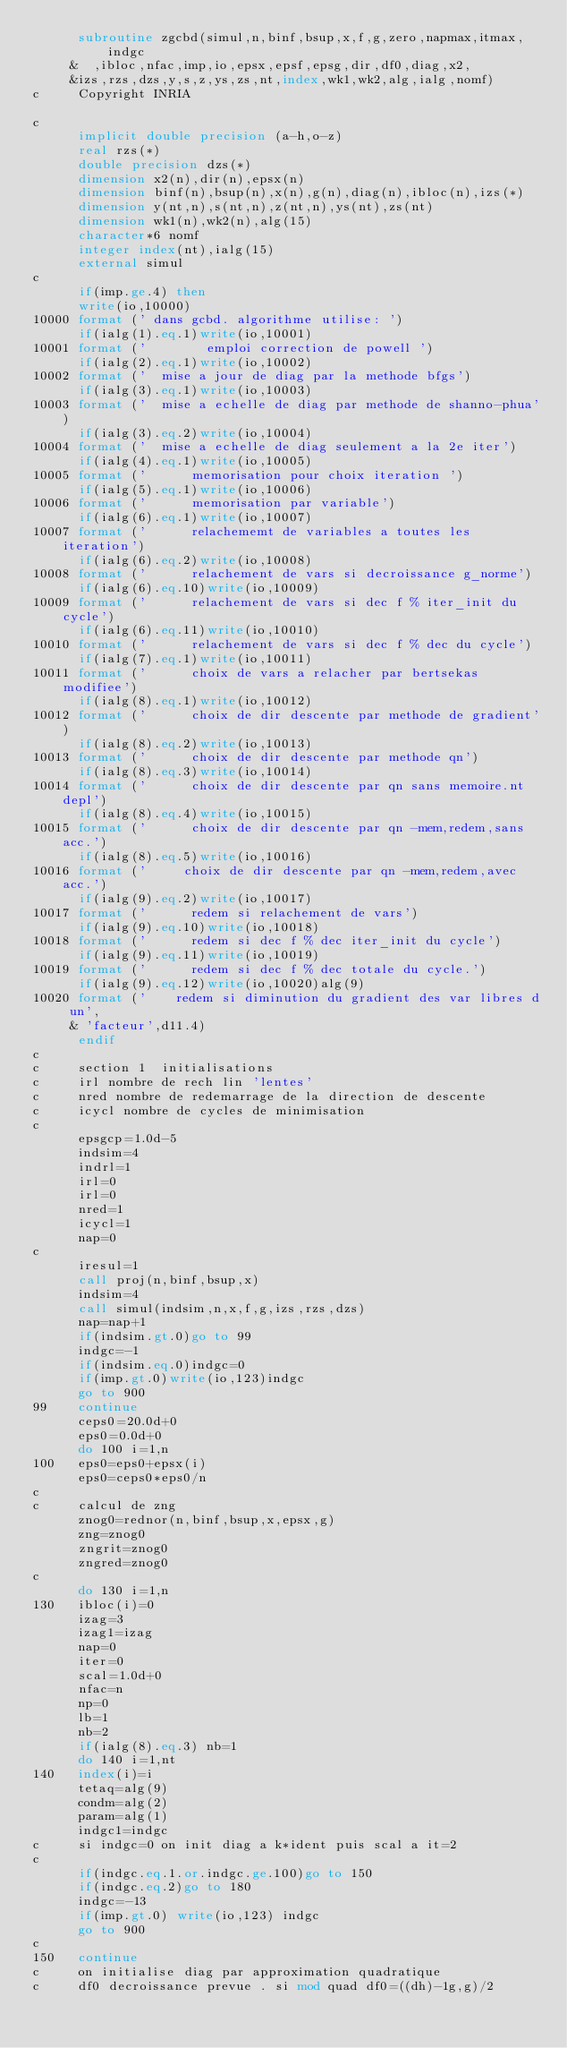Convert code to text. <code><loc_0><loc_0><loc_500><loc_500><_FORTRAN_>      subroutine zgcbd(simul,n,binf,bsup,x,f,g,zero,napmax,itmax,indgc
     &  ,ibloc,nfac,imp,io,epsx,epsf,epsg,dir,df0,diag,x2,
     &izs,rzs,dzs,y,s,z,ys,zs,nt,index,wk1,wk2,alg,ialg,nomf)
c     Copyright INRIA

c
      implicit double precision (a-h,o-z)
      real rzs(*)
      double precision dzs(*)
      dimension x2(n),dir(n),epsx(n)
      dimension binf(n),bsup(n),x(n),g(n),diag(n),ibloc(n),izs(*)
      dimension y(nt,n),s(nt,n),z(nt,n),ys(nt),zs(nt)
      dimension wk1(n),wk2(n),alg(15)
      character*6 nomf
      integer index(nt),ialg(15)
      external simul
c
      if(imp.ge.4) then
      write(io,10000)
10000 format (' dans gcbd. algorithme utilise: ')
      if(ialg(1).eq.1)write(io,10001)
10001 format ('        emploi correction de powell ')
      if(ialg(2).eq.1)write(io,10002)
10002 format ('  mise a jour de diag par la methode bfgs')
      if(ialg(3).eq.1)write(io,10003)
10003 format ('  mise a echelle de diag par methode de shanno-phua')
      if(ialg(3).eq.2)write(io,10004)
10004 format ('  mise a echelle de diag seulement a la 2e iter')
      if(ialg(4).eq.1)write(io,10005)
10005 format ('      memorisation pour choix iteration ')
      if(ialg(5).eq.1)write(io,10006)
10006 format ('      memorisation par variable')
      if(ialg(6).eq.1)write(io,10007)
10007 format ('      relachememt de variables a toutes les iteration')
      if(ialg(6).eq.2)write(io,10008)
10008 format ('      relachement de vars si decroissance g_norme')
      if(ialg(6).eq.10)write(io,10009)
10009 format ('      relachement de vars si dec f % iter_init du cycle')
      if(ialg(6).eq.11)write(io,10010)
10010 format ('      relachement de vars si dec f % dec du cycle')
      if(ialg(7).eq.1)write(io,10011)
10011 format ('      choix de vars a relacher par bertsekas modifiee')
      if(ialg(8).eq.1)write(io,10012)
10012 format ('      choix de dir descente par methode de gradient')
      if(ialg(8).eq.2)write(io,10013)
10013 format ('      choix de dir descente par methode qn')
      if(ialg(8).eq.3)write(io,10014)
10014 format ('      choix de dir descente par qn sans memoire.nt depl')
      if(ialg(8).eq.4)write(io,10015)
10015 format ('      choix de dir descente par qn -mem,redem,sans acc.')
      if(ialg(8).eq.5)write(io,10016)
10016 format ('     choix de dir descente par qn -mem,redem,avec acc.')
      if(ialg(9).eq.2)write(io,10017)
10017 format ('      redem si relachement de vars')
      if(ialg(9).eq.10)write(io,10018)
10018 format ('      redem si dec f % dec iter_init du cycle')
      if(ialg(9).eq.11)write(io,10019)
10019 format ('      redem si dec f % dec totale du cycle.')
      if(ialg(9).eq.12)write(io,10020)alg(9)
10020 format ('    redem si diminution du gradient des var libres d un',
     & 'facteur',d11.4)
      endif
c
c     section 1  initialisations
c     irl nombre de rech lin 'lentes'
c     nred nombre de redemarrage de la direction de descente
c     icycl nombre de cycles de minimisation
c
      epsgcp=1.0d-5
      indsim=4
      indrl=1
      irl=0
      irl=0
      nred=1
      icycl=1
      nap=0
c
      iresul=1
      call proj(n,binf,bsup,x)
      indsim=4
      call simul(indsim,n,x,f,g,izs,rzs,dzs)
      nap=nap+1
      if(indsim.gt.0)go to 99
      indgc=-1
      if(indsim.eq.0)indgc=0
      if(imp.gt.0)write(io,123)indgc
      go to 900
99    continue
      ceps0=20.0d+0
      eps0=0.0d+0
      do 100 i=1,n
100   eps0=eps0+epsx(i)
      eps0=ceps0*eps0/n
c
c     calcul de zng
      znog0=rednor(n,binf,bsup,x,epsx,g)
      zng=znog0
      zngrit=znog0
      zngred=znog0
c
      do 130 i=1,n
130   ibloc(i)=0
      izag=3
      izag1=izag
      nap=0
      iter=0
      scal=1.0d+0
      nfac=n
      np=0
      lb=1
      nb=2
      if(ialg(8).eq.3) nb=1
      do 140 i=1,nt
140   index(i)=i
      tetaq=alg(9)
      condm=alg(2)
      param=alg(1)
      indgc1=indgc
c     si indgc=0 on init diag a k*ident puis scal a it=2
c
      if(indgc.eq.1.or.indgc.ge.100)go to 150
      if(indgc.eq.2)go to 180
      indgc=-13
      if(imp.gt.0) write(io,123) indgc
      go to 900
c
150   continue
c     on initialise diag par approximation quadratique
c     df0 decroissance prevue . si mod quad df0=((dh)-1g,g)/2</code> 